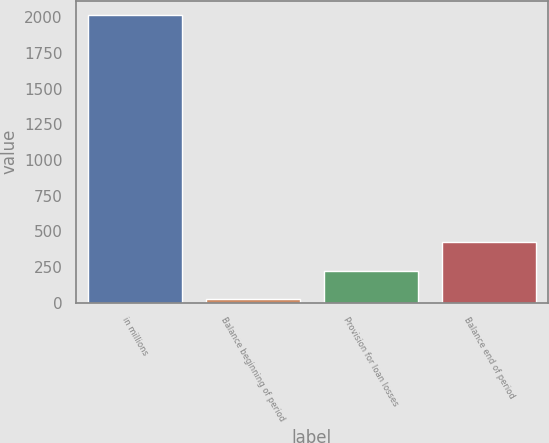Convert chart to OTSL. <chart><loc_0><loc_0><loc_500><loc_500><bar_chart><fcel>in millions<fcel>Balance beginning of period<fcel>Provision for loan losses<fcel>Balance end of period<nl><fcel>2013<fcel>24<fcel>222.9<fcel>421.8<nl></chart> 